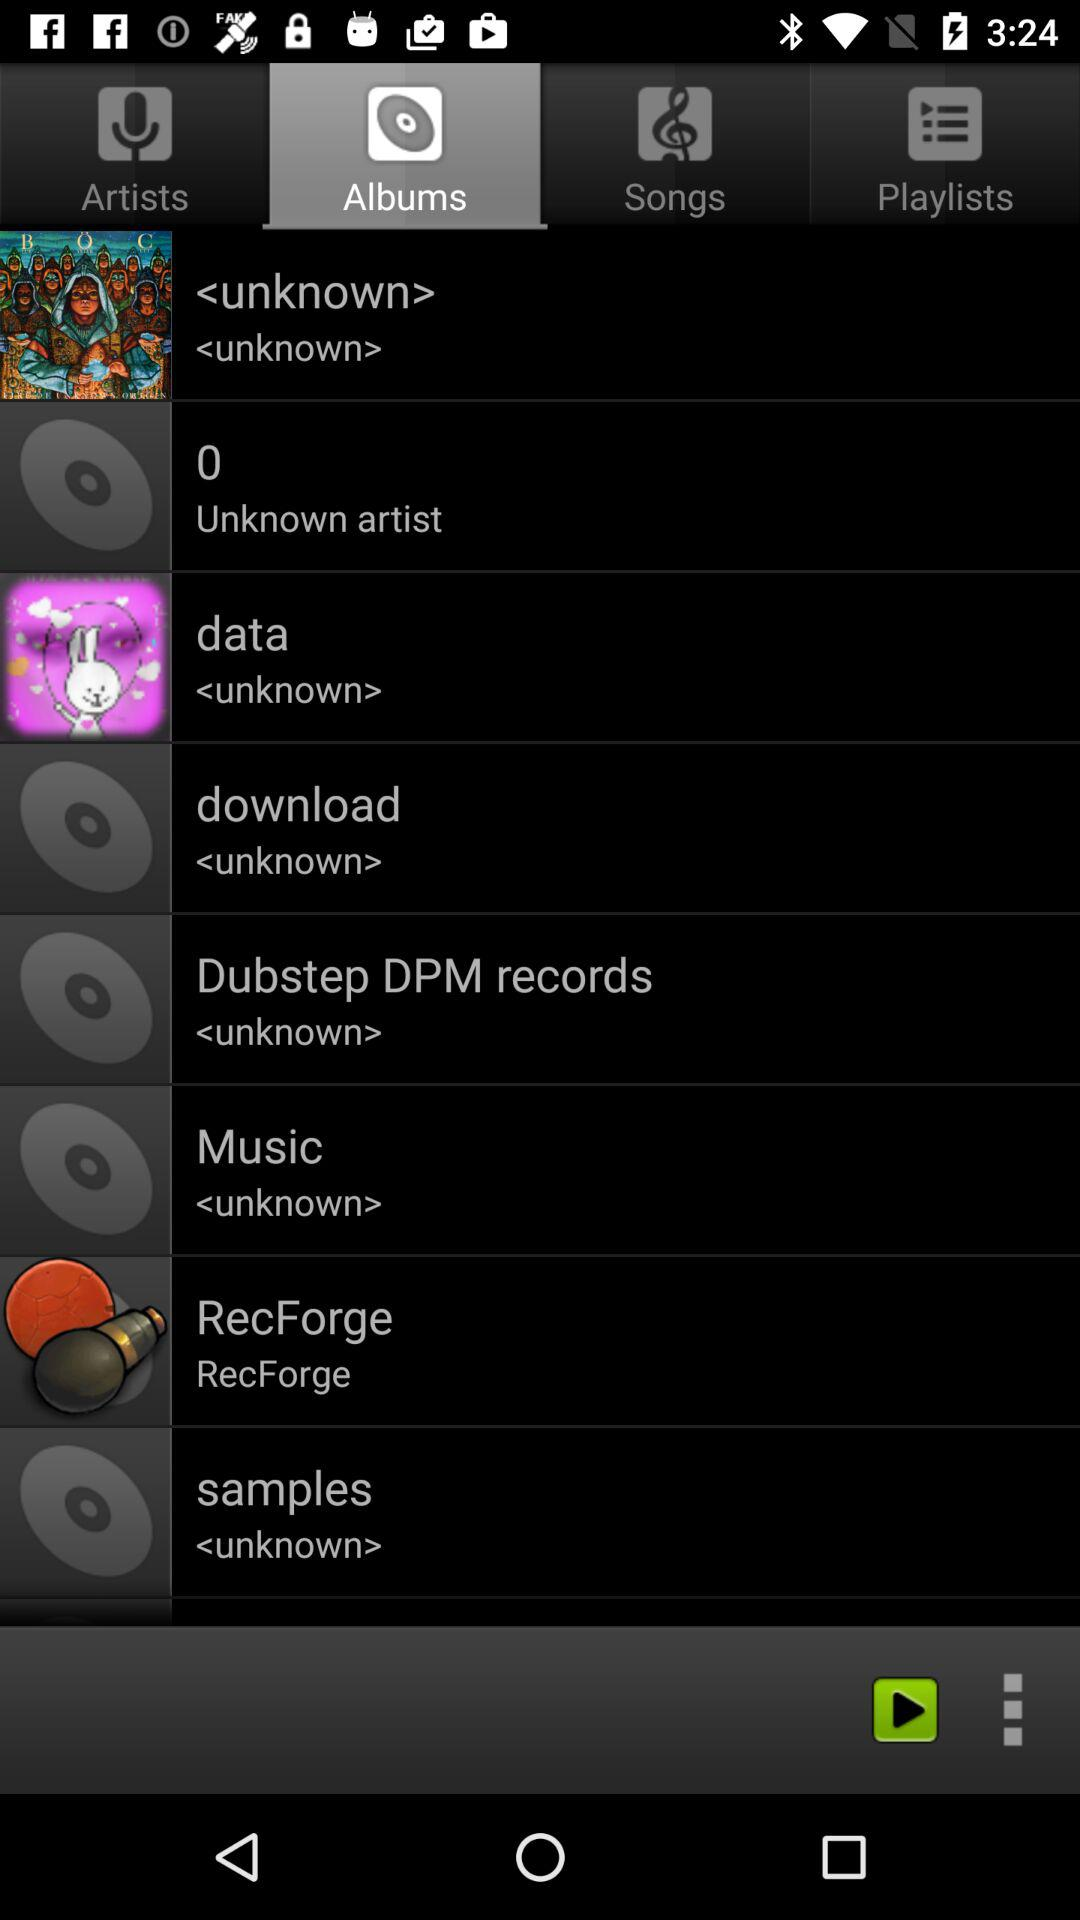Which tab is selected? The selected tab is "Albums". 